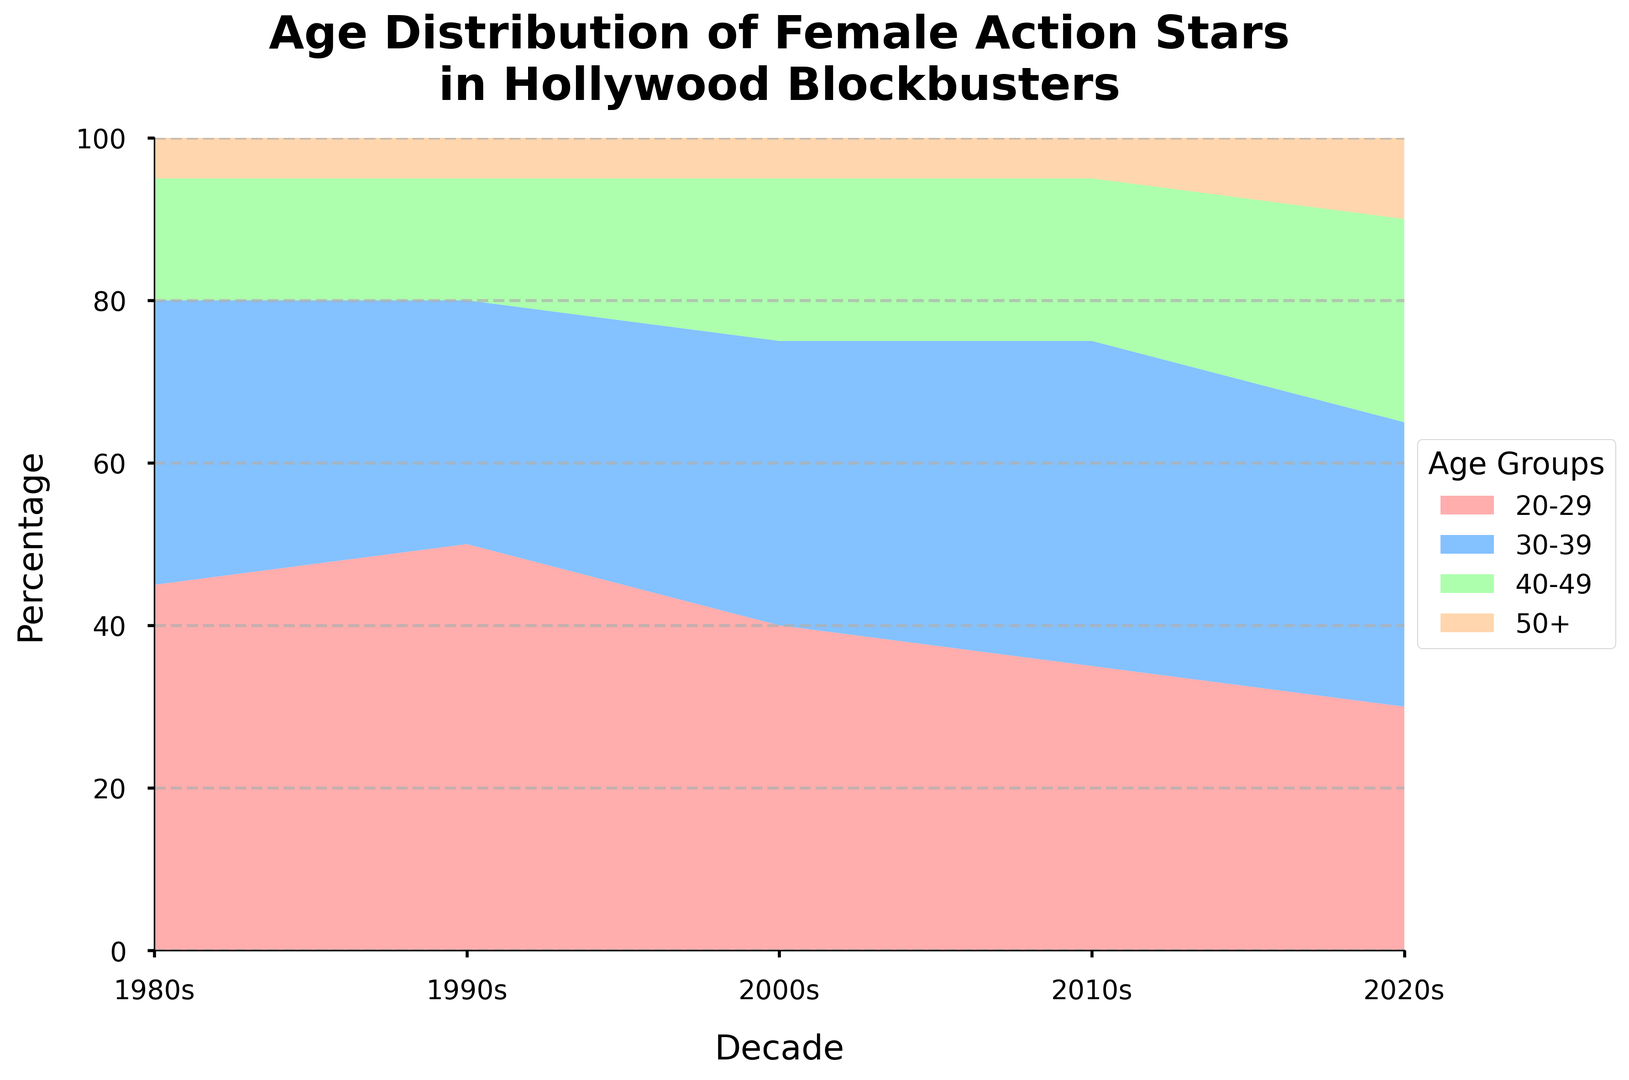What's the trend in the percentage of female action stars aged 20-29 over the decades? We observe a decreasing trend in the percentage of female action stars aged 20-29: 1980s (45%), 1990s (50%), 2000s (40%), 2010s (35%), 2020s (30%).
Answer: Decreasing Which age group saw an increase in their percentage from the 1980s to the 2020s? Comparing the data for each age group between the 1980s and the 2020s: 20-29 decreased (45% to 30%), 30-39 remained constant (35% to 35%), 40-49 increased (15% to 25%), and 50+ increased (5% to 10%). Thus, the 40-49 and 50+ age groups saw an increase in their percentages.
Answer: 40-49 and 50+ What was the percentage change in the 40-49 age group from the 2000s to the 2020s? The percentage for the 40-49 age group in the 2000s was 20%, and in the 2020s it is 25%. The percentage change can be calculated as ((25 - 20) / 20) * 100 = 25%.
Answer: 25% Which decade had the highest percentage of female action stars aged 30-39? Observing the 30-39 age group across the decades: 1980s (35%), 1990s (30%), 2000s (35%), 2010s (40%), 2020s (35%). The 2010s had the highest percentage at 40%.
Answer: 2010s How does the sum of the percentages for age groups 40-49 and 50+ in the 2020s compare to the same sum in the 1980s? In the 1980s, the sum for age groups 40-49 and 50+ is 15% + 5% = 20%. In the 2020s, the sum is 25% + 10% = 35%. Thus, the sum in the 2020s is greater than in the 1980s.
Answer: The sum is greater in the 2020s What visual change is notable for the age group 30-39 from the 1980s to the 2010s? The visual representation shows that the area for the 30-39 age group expanded from the 1980s (35%) to the 2010s (40%), indicating an increase.
Answer: Expansion In which decade did the age group 50+ start showing a noticeable increase? Observing the data for the 50+ age group: 1980s (5%), 1990s (5%), 2000s (5%), 2010s (5%), 2020s (10%). A noticeable increase appears in the 2020s.
Answer: 2020s Which age group had the most stable percentage over the decades? Evaluating the data for age groups across the decades: 20-29 (decreasing), 30-39 (fluctuating), 40-49 (increasing), 50+ (slightly increasing then stable). The 50+ age group's percentages (5%, 5%, 5%, 5%, 10%) has been the most stable overall.
Answer: 50+ 